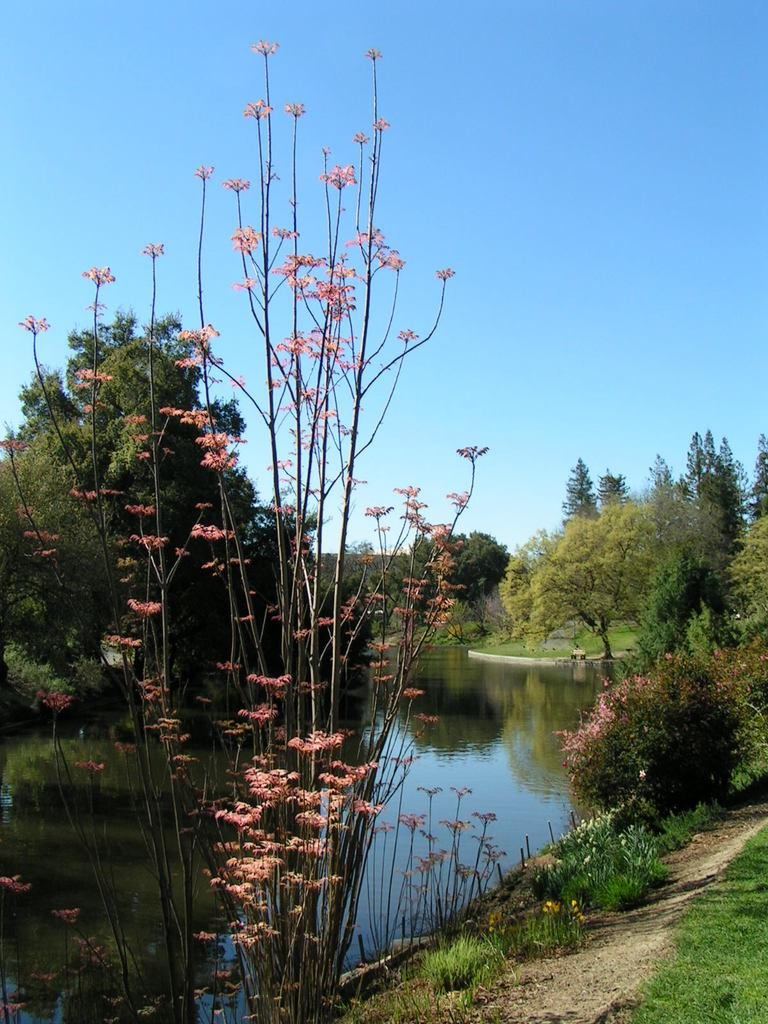What type of vegetation can be seen in the image? There are trees in the image. What else can be seen on the ground in the image? There is grass in the image. What is the water feature in the image? The water is visible in the image. What can be seen in the background of the image? The sky is visible in the background of the image. Can you see a board floating on the water in the image? There is no board visible in the image; only trees, grass, water, and sky are present. Is there a snail crawling on the grass in the image? There is no snail present in the image; only trees, grass, water, and sky are visible. 